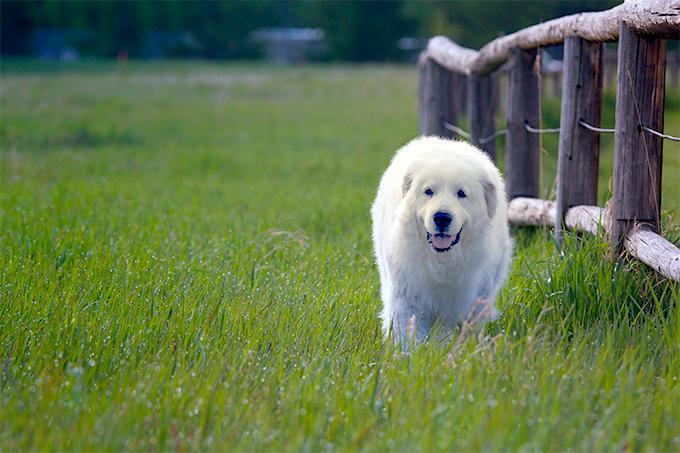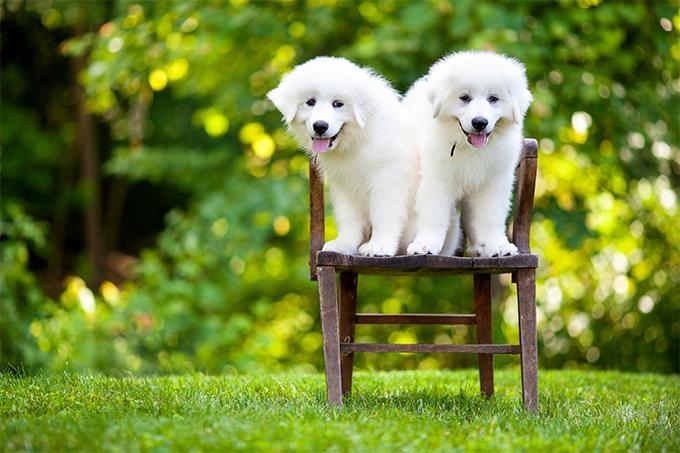The first image is the image on the left, the second image is the image on the right. Evaluate the accuracy of this statement regarding the images: "In at least one of the images, a white dog is laying down in grass". Is it true? Answer yes or no. No. The first image is the image on the left, the second image is the image on the right. Considering the images on both sides, is "The right image contains one white dog that is laying down in the grass." valid? Answer yes or no. No. 